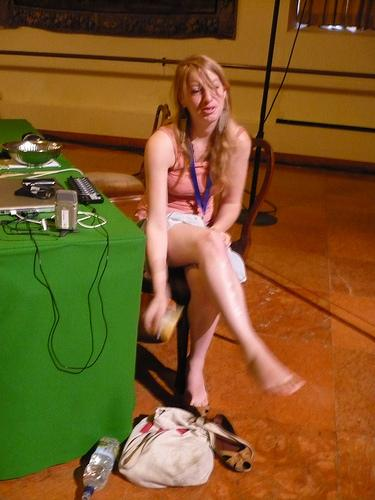How many shoes are visible in the image, and what color are they? One shoe is visible, and it is brown. In the image, what is the color and state of the woman's footwear? The woman is barefoot. Briefly describe the flooring in the room. The floor has brown tile. What is the color and opacity of the water bottle on the floor? The water bottle is transparent. List two objects that can be found on the green table. A silver bowl and some electronic devices are on the table. What color and material is the bag on the floor? The bag is white and made of cloth. Identify the color of the tablecloth. The tablecloth is green. Is the woman in the image sitting or standing? Describe her position. The woman is sitting down. What kind of container can be found on the floor? There is a water bottle on the floor. Provide a short description of the woman's outfit. The woman is wearing a peach-colored tank top. 